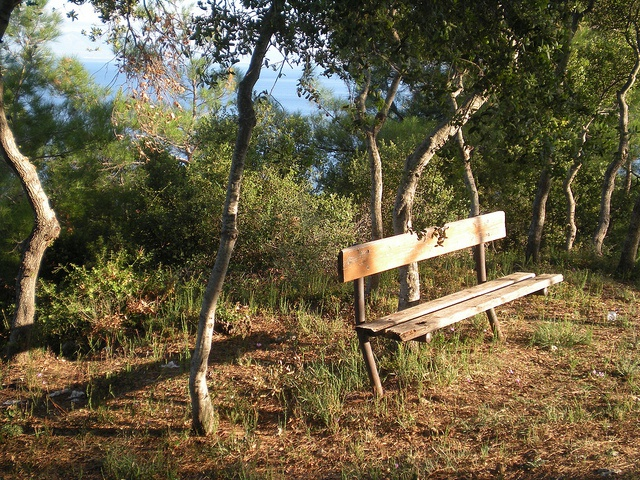Describe the objects in this image and their specific colors. I can see a bench in black, beige, tan, and olive tones in this image. 